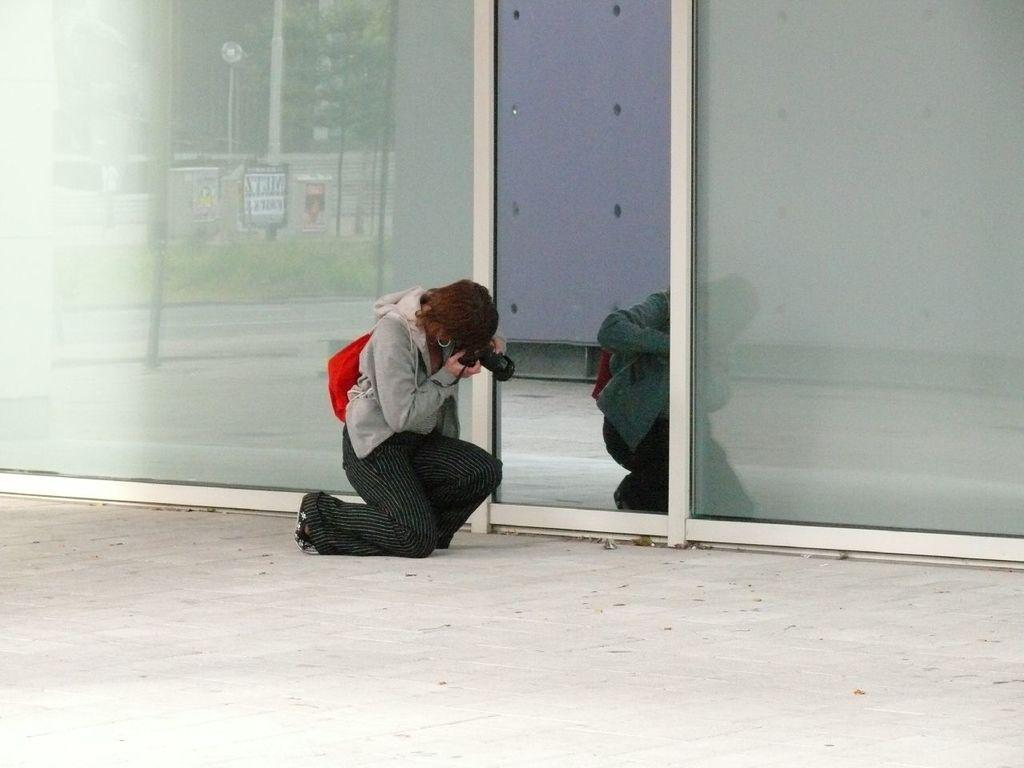What is the person in the image doing? The person is holding a camera in the image. What type of walls can be seen in the image? There are glass walls in the image. Can you describe the reflected image on the left side of the image? There is a reflected image on the left side of the image. Where can you find the best deals on fruits and vegetables in the image? There is no market or mention of fruits and vegetables in the image. 